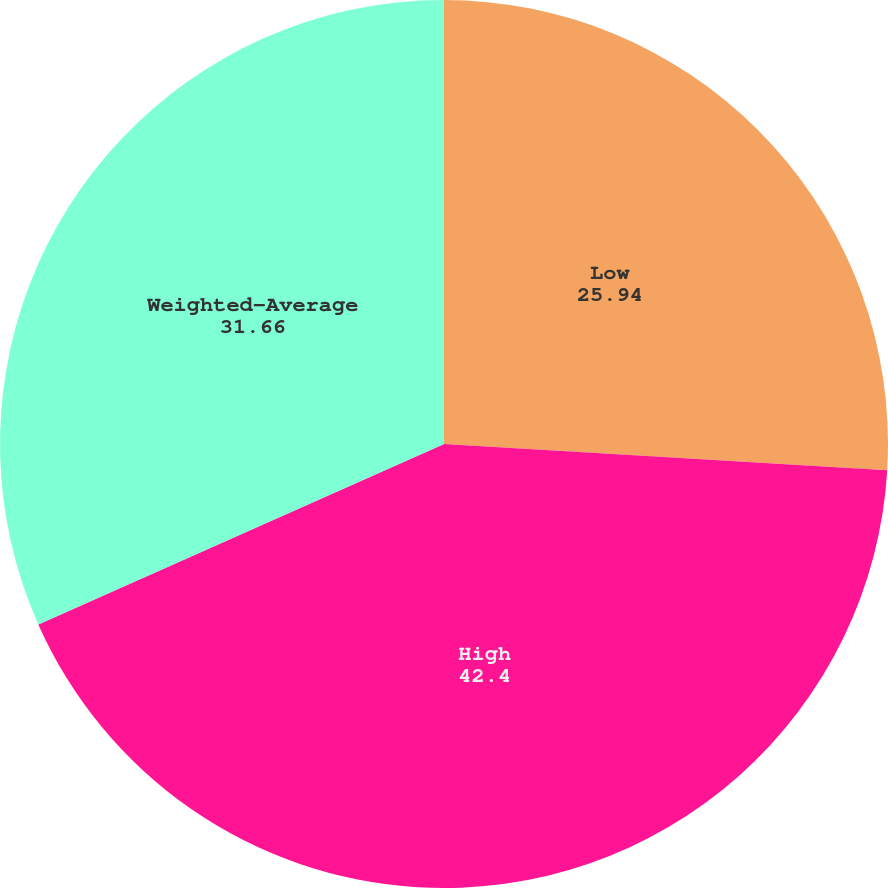Convert chart. <chart><loc_0><loc_0><loc_500><loc_500><pie_chart><fcel>Low<fcel>High<fcel>Weighted-Average<nl><fcel>25.94%<fcel>42.4%<fcel>31.66%<nl></chart> 